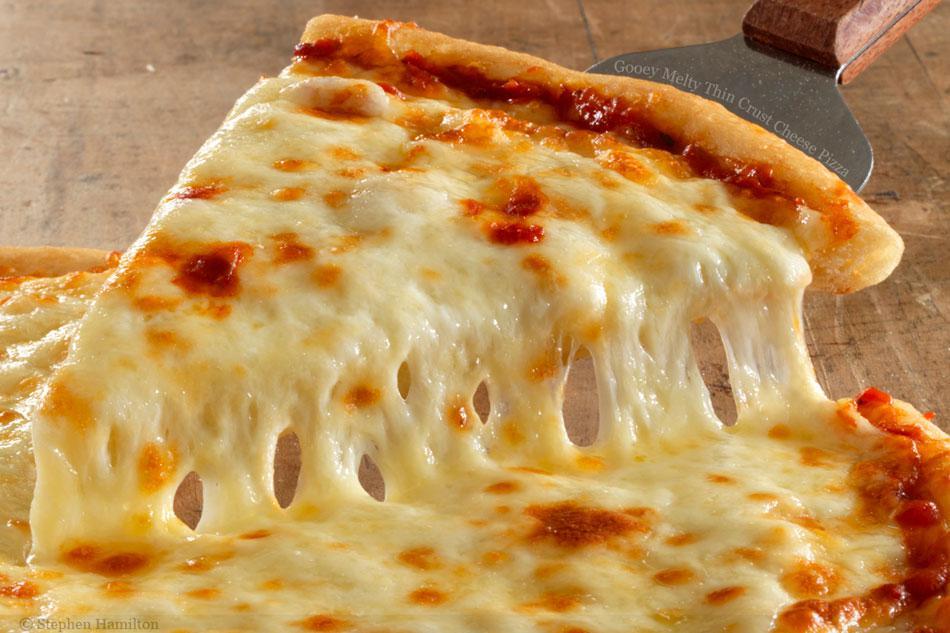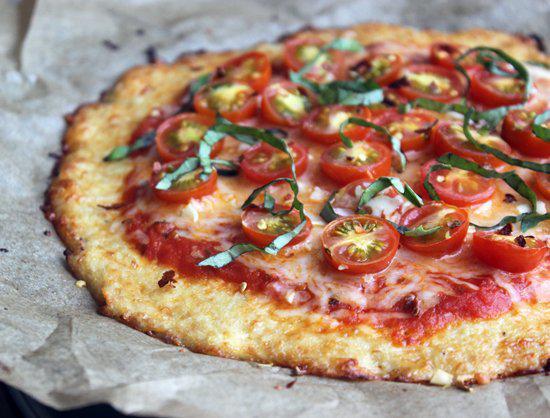The first image is the image on the left, the second image is the image on the right. Evaluate the accuracy of this statement regarding the images: "One image shows a pizza with pepperoni as a topping and the other image shows a pizza with no pepperoni.". Is it true? Answer yes or no. No. 